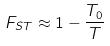<formula> <loc_0><loc_0><loc_500><loc_500>F _ { S T } \approx 1 - \frac { T _ { 0 } } { T }</formula> 